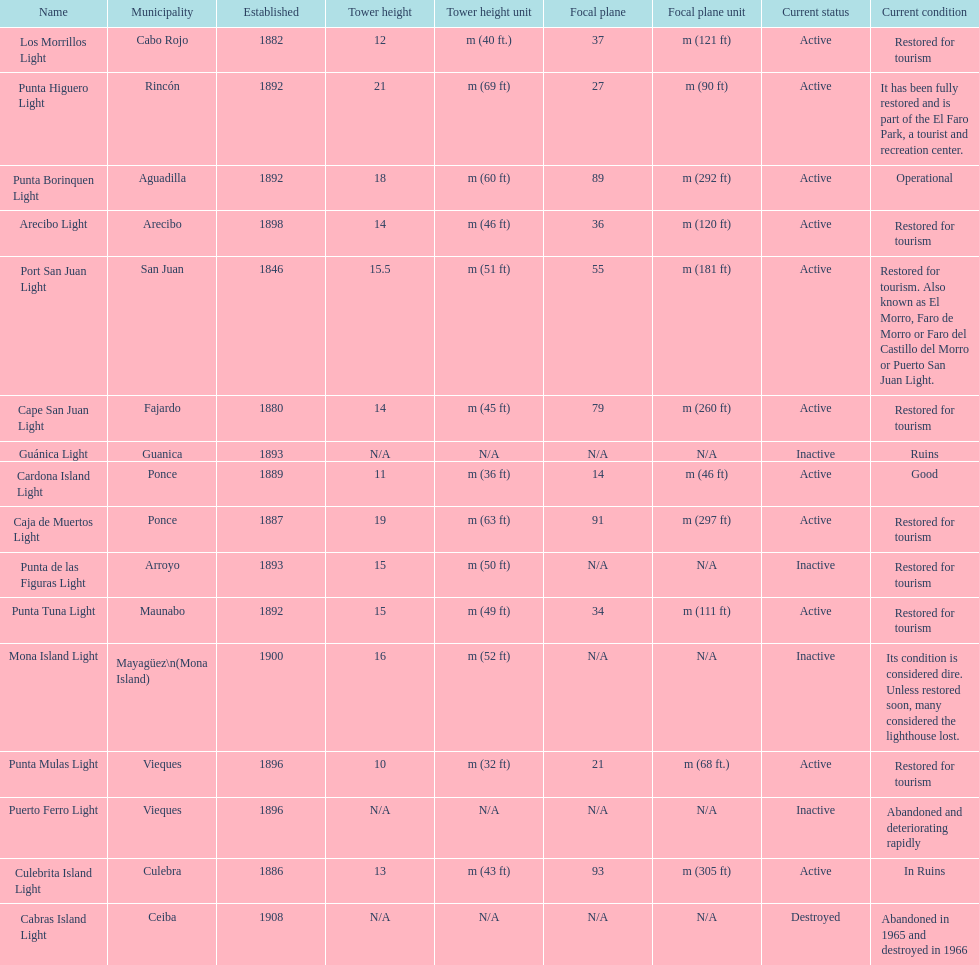The difference in years from 1882 to 1889 7. Can you give me this table as a dict? {'header': ['Name', 'Municipality', 'Established', 'Tower height', 'Tower height unit', 'Focal plane', 'Focal plane unit', 'Current status', 'Current condition'], 'rows': [['Los Morrillos Light', 'Cabo Rojo', '1882', '12', 'm (40 ft.)', '37', 'm (121 ft)', 'Active', 'Restored for tourism'], ['Punta Higuero Light', 'Rincón', '1892', '21', 'm (69 ft)', '27', 'm (90 ft)', 'Active', 'It has been fully restored and is part of the El Faro Park, a tourist and recreation center.'], ['Punta Borinquen Light', 'Aguadilla', '1892', '18', 'm (60 ft)', '89', 'm (292 ft)', 'Active', 'Operational'], ['Arecibo Light', 'Arecibo', '1898', '14', 'm (46 ft)', '36', 'm (120 ft)', 'Active', 'Restored for tourism'], ['Port San Juan Light', 'San Juan', '1846', '15.5', 'm (51 ft)', '55', 'm (181 ft)', 'Active', 'Restored for tourism. Also known as El Morro, Faro de Morro or Faro del Castillo del Morro or Puerto San Juan Light.'], ['Cape San Juan Light', 'Fajardo', '1880', '14', 'm (45 ft)', '79', 'm (260 ft)', 'Active', 'Restored for tourism'], ['Guánica Light', 'Guanica', '1893', 'N/A', 'N/A', 'N/A', 'N/A', 'Inactive', 'Ruins'], ['Cardona Island Light', 'Ponce', '1889', '11', 'm (36 ft)', '14', 'm (46 ft)', 'Active', 'Good'], ['Caja de Muertos Light', 'Ponce', '1887', '19', 'm (63 ft)', '91', 'm (297 ft)', 'Active', 'Restored for tourism'], ['Punta de las Figuras Light', 'Arroyo', '1893', '15', 'm (50 ft)', 'N/A', 'N/A', 'Inactive', 'Restored for tourism'], ['Punta Tuna Light', 'Maunabo', '1892', '15', 'm (49 ft)', '34', 'm (111 ft)', 'Active', 'Restored for tourism'], ['Mona Island Light', 'Mayagüez\\n(Mona Island)', '1900', '16', 'm (52 ft)', 'N/A', 'N/A', 'Inactive', 'Its condition is considered dire. Unless restored soon, many considered the lighthouse lost.'], ['Punta Mulas Light', 'Vieques', '1896', '10', 'm (32 ft)', '21', 'm (68 ft.)', 'Active', 'Restored for tourism'], ['Puerto Ferro Light', 'Vieques', '1896', 'N/A', 'N/A', 'N/A', 'N/A', 'Inactive', 'Abandoned and deteriorating rapidly'], ['Culebrita Island Light', 'Culebra', '1886', '13', 'm (43 ft)', '93', 'm (305 ft)', 'Active', 'In Ruins'], ['Cabras Island Light', 'Ceiba', '1908', 'N/A', 'N/A', 'N/A', 'N/A', 'Destroyed', 'Abandoned in 1965 and destroyed in 1966']]} 